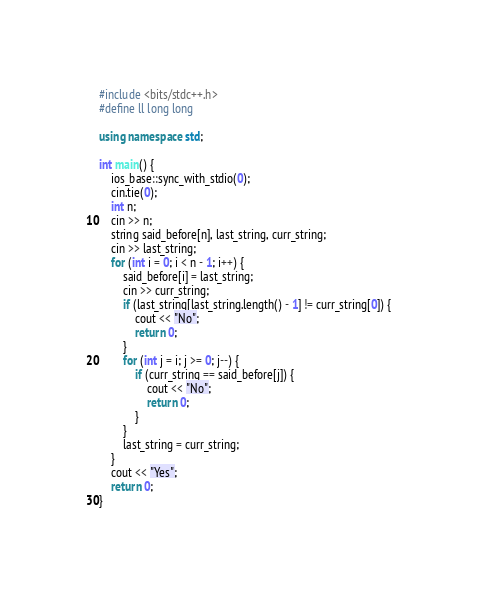Convert code to text. <code><loc_0><loc_0><loc_500><loc_500><_C++_>#include <bits/stdc++.h>
#define ll long long

using namespace std;

int main() {
    ios_base::sync_with_stdio(0);
    cin.tie(0);
    int n;
    cin >> n;
    string said_before[n], last_string, curr_string;
    cin >> last_string;
    for (int i = 0; i < n - 1; i++) {
        said_before[i] = last_string;
        cin >> curr_string;
        if (last_string[last_string.length() - 1] != curr_string[0]) {
            cout << "No";
            return 0;
        }
        for (int j = i; j >= 0; j--) {
            if (curr_string == said_before[j]) {
                cout << "No";
                return 0;
            }
        }
        last_string = curr_string;
    }
    cout << "Yes";
    return 0;
}

</code> 